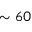<formula> <loc_0><loc_0><loc_500><loc_500>\sim 6 0</formula> 